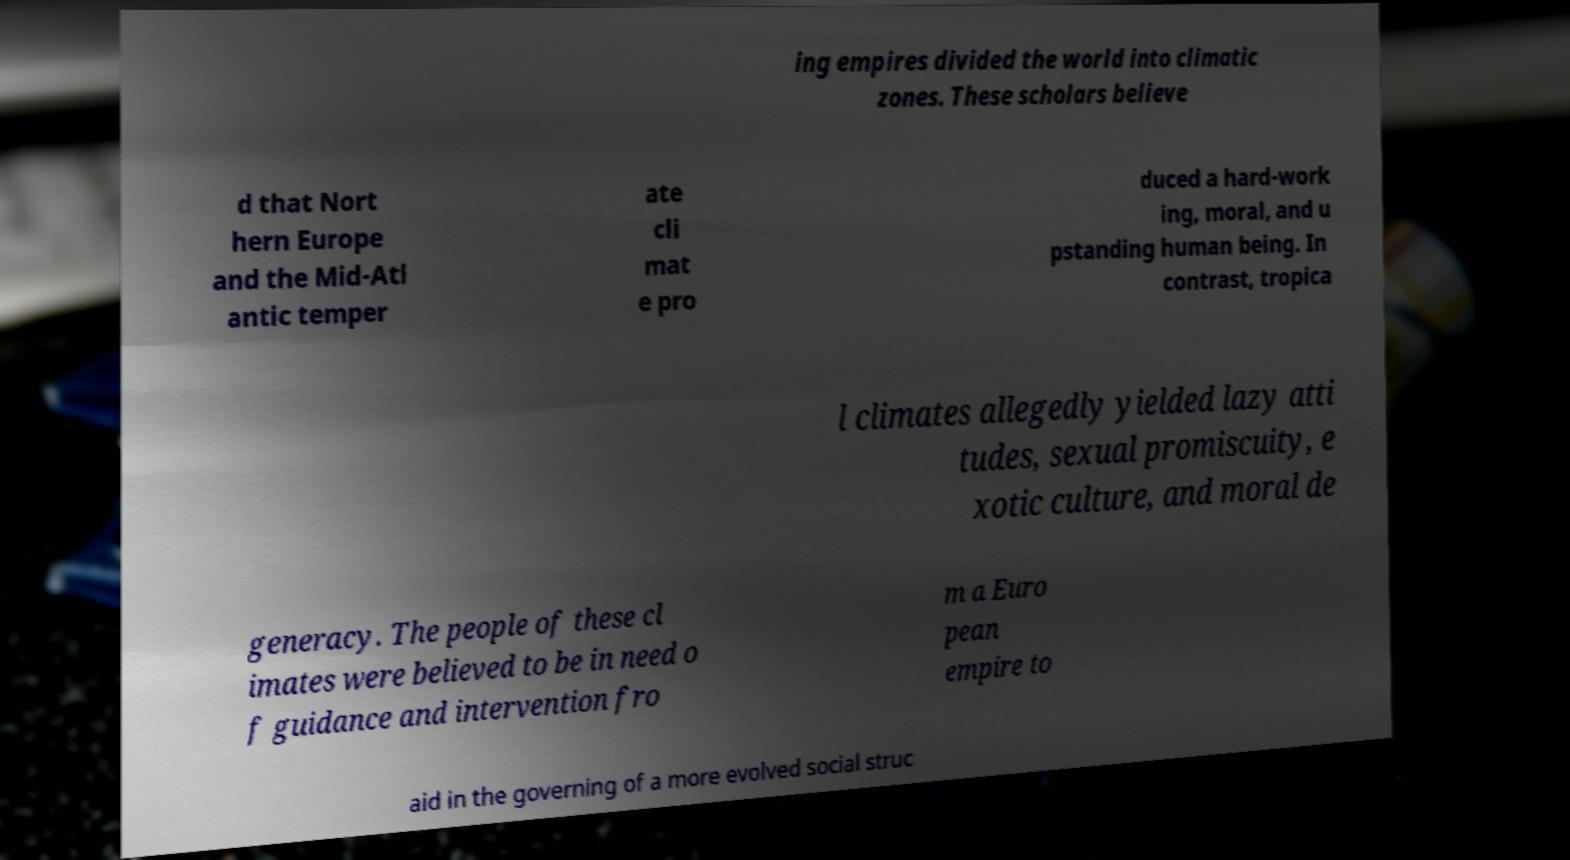There's text embedded in this image that I need extracted. Can you transcribe it verbatim? ing empires divided the world into climatic zones. These scholars believe d that Nort hern Europe and the Mid-Atl antic temper ate cli mat e pro duced a hard-work ing, moral, and u pstanding human being. In contrast, tropica l climates allegedly yielded lazy atti tudes, sexual promiscuity, e xotic culture, and moral de generacy. The people of these cl imates were believed to be in need o f guidance and intervention fro m a Euro pean empire to aid in the governing of a more evolved social struc 